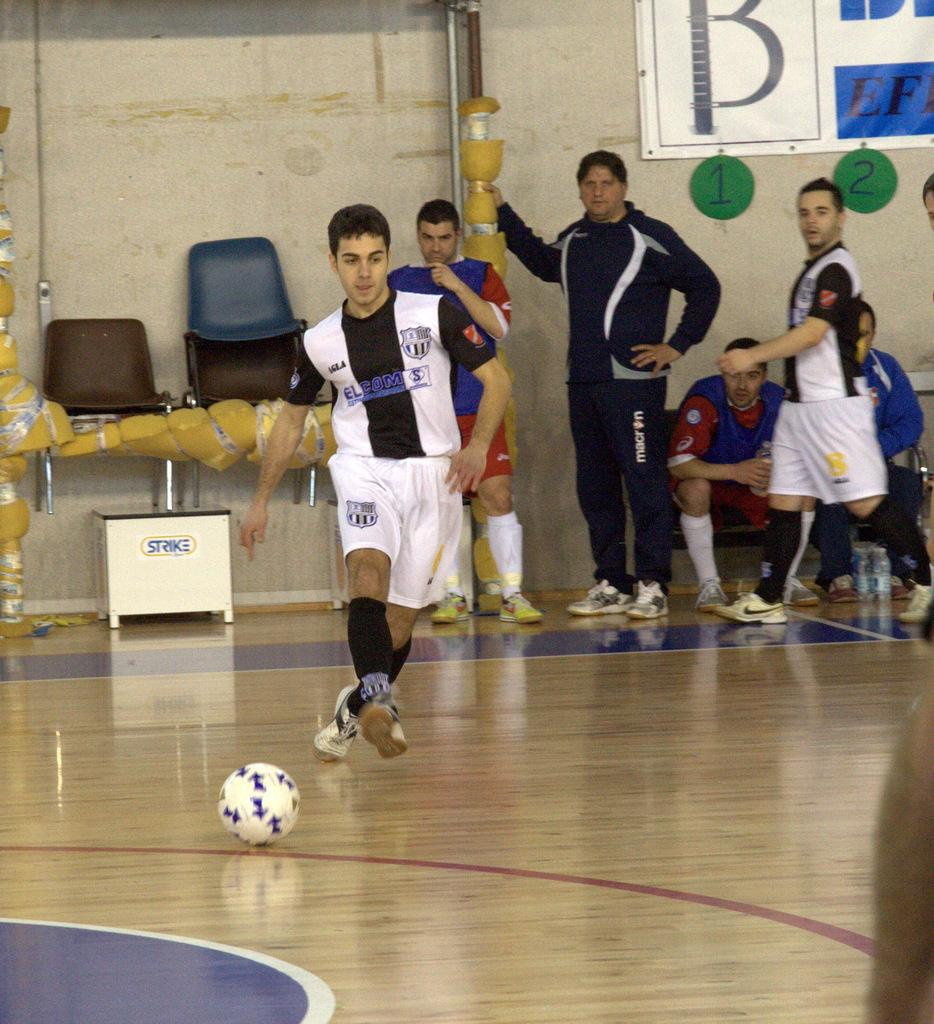What object can be seen in the image that is typically used for playing games or sports? There is a ball in the image. What type of furniture is present in the image? There are chairs in the image. What is the man in the image doing? A man is running on the ground in the image. What can be seen in the background of the image? There is a group of people and bottles in the background of the image. What is on the wall in the background of the image? There is a banner on a wall in the background of the image. Is the man in the image trying to escape from quicksand? There is no quicksand present in the image, and the man is running on the ground, not trying to escape from anything. How does the banner on the wall in the background of the image get washed? The image does not show any washing or cleaning process for the banner; it only shows the banner on the wall. 